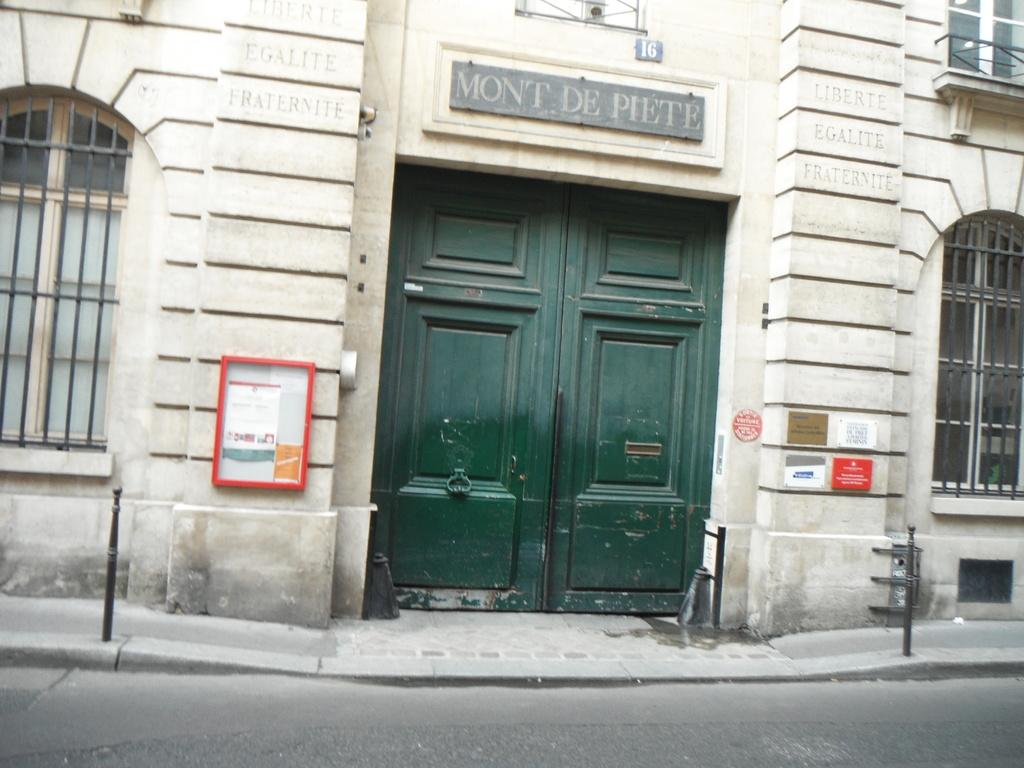What type of structure is visible in the image? There is a building in the image. What features can be observed on the building? The building has windows. What is the purpose of the fence in the image? The fence is likely used to separate or enclose an area. How can someone enter the building? There is a door in the image that can be used to enter the building. What is the pathway for pedestrians in the image? There is a footpath in the image for people to walk on. What is the small pole in the image used for? The purpose of the small pole is not clear from the image, but it could be used for signage or lighting. What is the board in the image used for? The board in the image is used for displaying text. What message is conveyed on the board? There is text on the board, but the specific message cannot be determined from the image. What is the main mode of transportation for vehicles in the image? There is a road in the image for vehicles to travel on. How many matches are on the tray in the image? There is no tray or matches present in the image. 